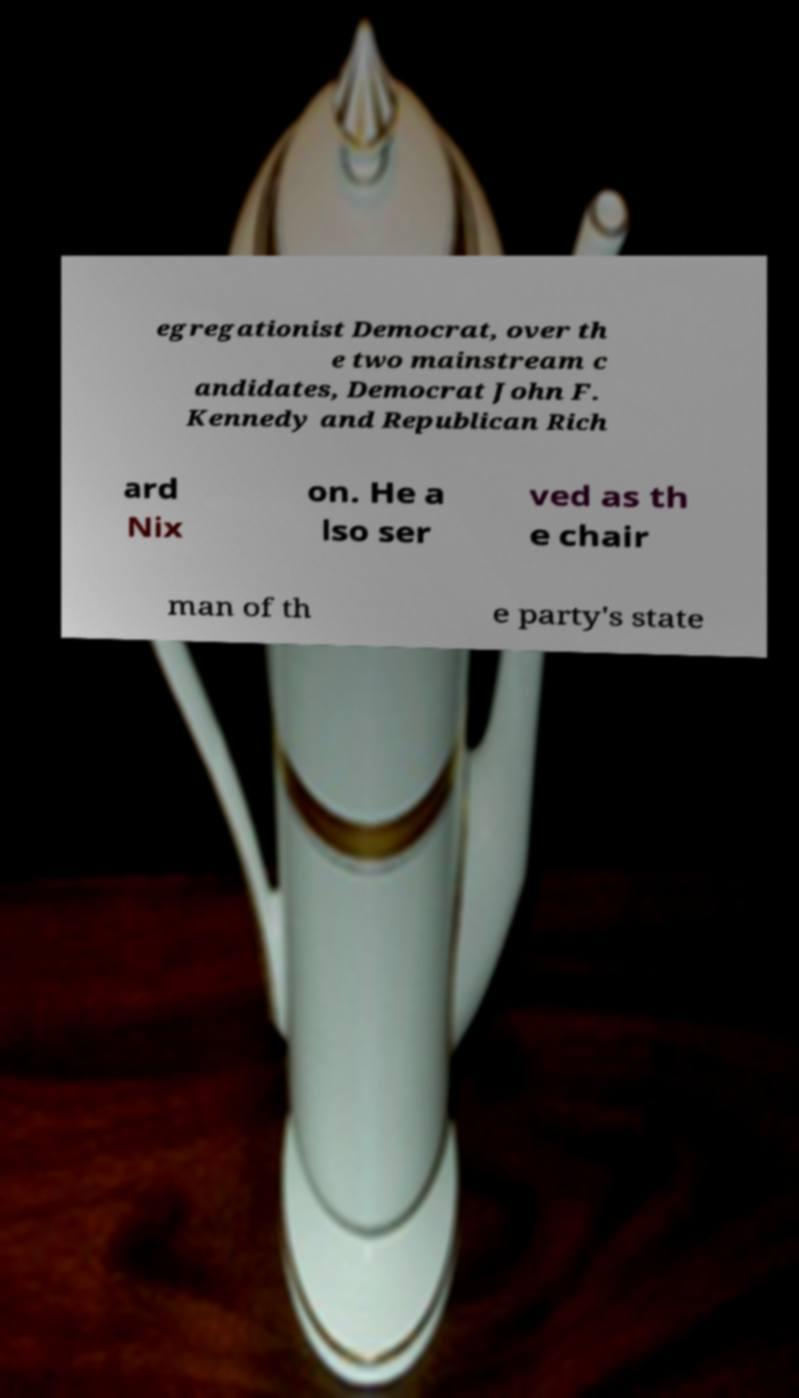There's text embedded in this image that I need extracted. Can you transcribe it verbatim? egregationist Democrat, over th e two mainstream c andidates, Democrat John F. Kennedy and Republican Rich ard Nix on. He a lso ser ved as th e chair man of th e party's state 